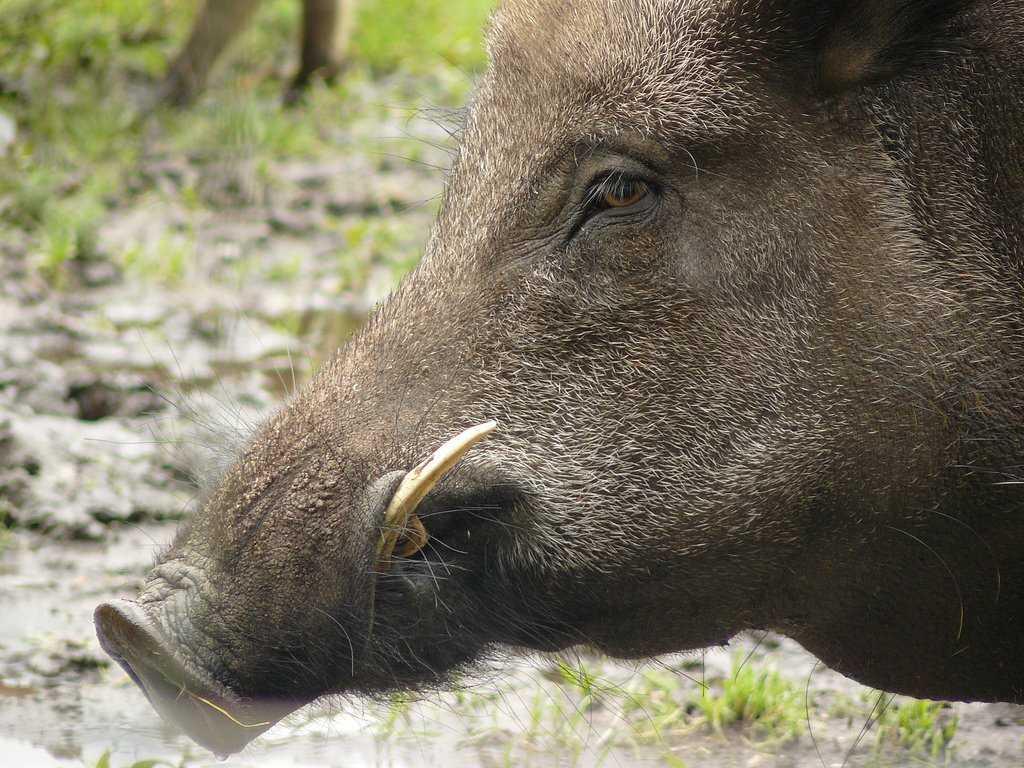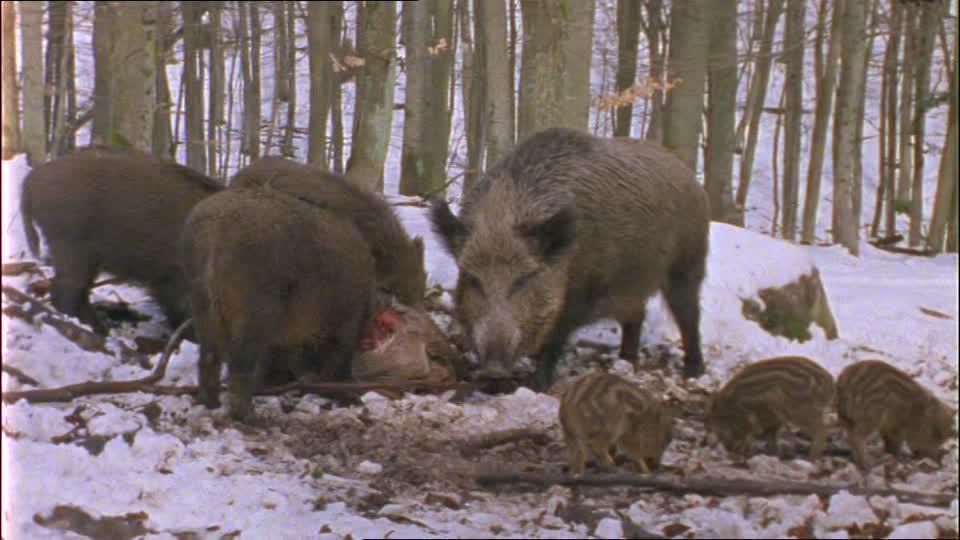The first image is the image on the left, the second image is the image on the right. For the images displayed, is the sentence "One images shows a human in close proximity to two boars." factually correct? Answer yes or no. No. The first image is the image on the left, the second image is the image on the right. Given the left and right images, does the statement "An image shows at least one wild pig standing by a carcass." hold true? Answer yes or no. Yes. 